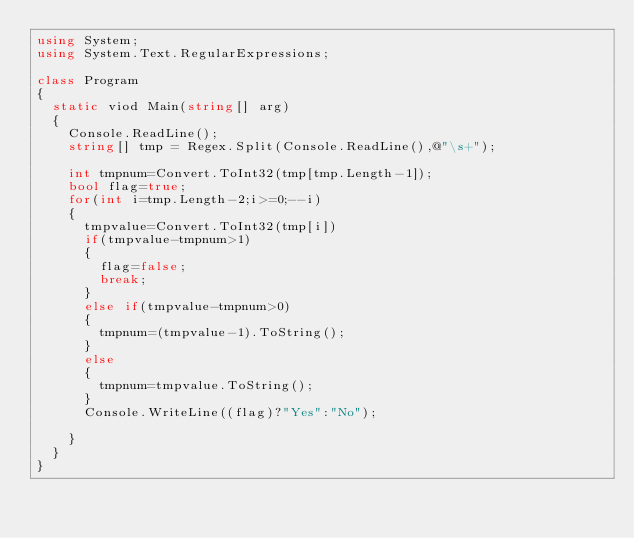Convert code to text. <code><loc_0><loc_0><loc_500><loc_500><_C#_>using System;
using System.Text.RegularExpressions;

class Program
{
  static viod Main(string[] arg)
  {
    Console.ReadLine();
    string[] tmp = Regex.Split(Console.ReadLine(),@"\s+");
    
    int tmpnum=Convert.ToInt32(tmp[tmp.Length-1]);
    bool flag=true;
    for(int i=tmp.Length-2;i>=0;--i)
    {
      tmpvalue=Convert.ToInt32(tmp[i])
      if(tmpvalue-tmpnum>1)
      {
        flag=false;
        break;
      }
      else if(tmpvalue-tmpnum>0)
      {
        tmpnum=(tmpvalue-1).ToString();
      }
      else
      {
        tmpnum=tmpvalue.ToString();
      }
      Console.WriteLine((flag)?"Yes":"No");
      
    }
  }
}</code> 